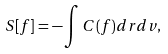<formula> <loc_0><loc_0><loc_500><loc_500>S [ f ] = - \int C ( f ) d { r } d { v } ,</formula> 